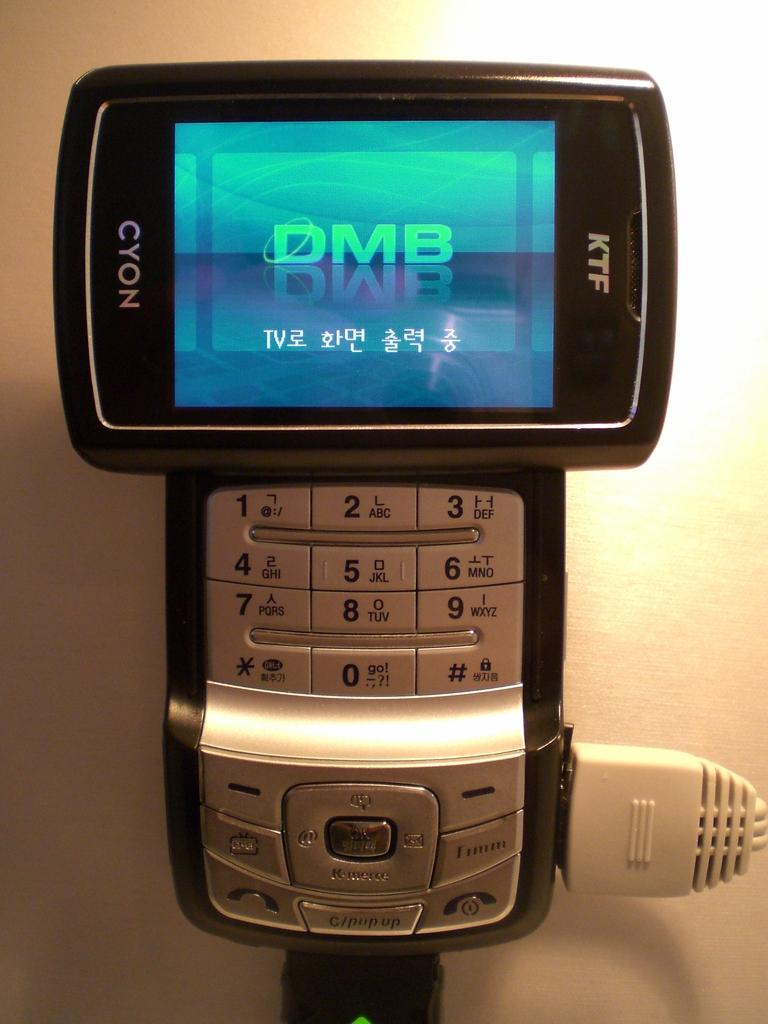Provide a one-sentence caption for the provided image. A KTF Cyon phone that is showing DMB on the screen. 